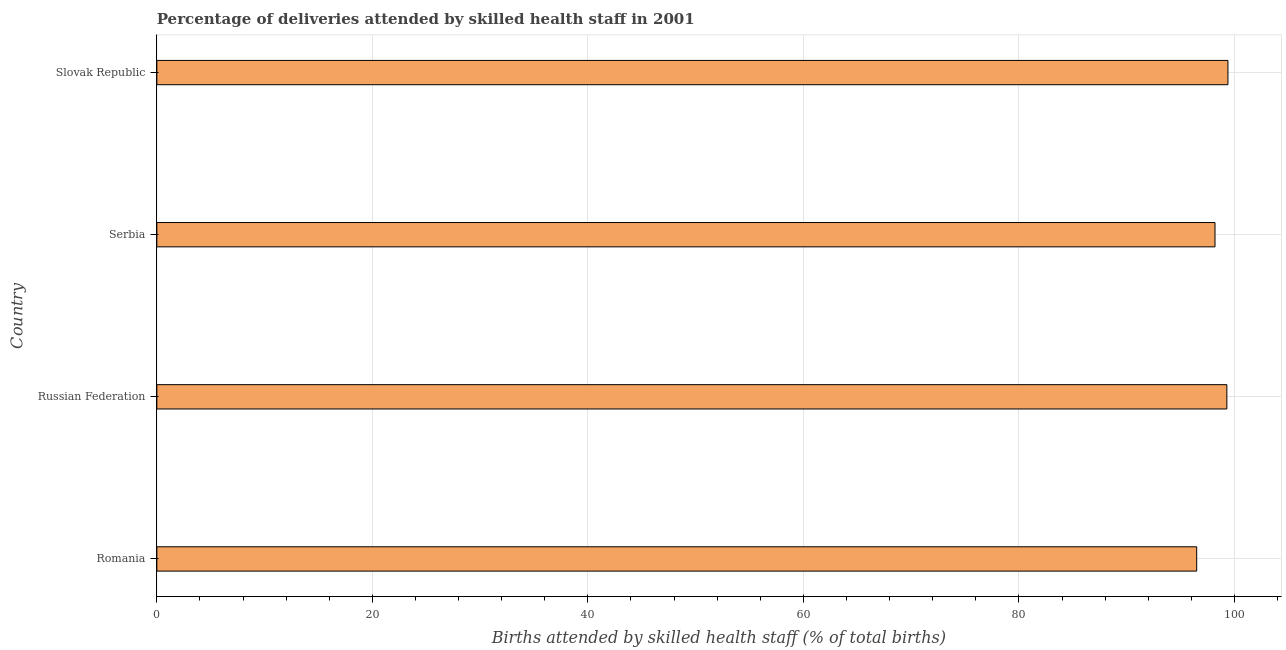Does the graph contain grids?
Ensure brevity in your answer.  Yes. What is the title of the graph?
Offer a terse response. Percentage of deliveries attended by skilled health staff in 2001. What is the label or title of the X-axis?
Provide a succinct answer. Births attended by skilled health staff (% of total births). What is the number of births attended by skilled health staff in Slovak Republic?
Ensure brevity in your answer.  99.4. Across all countries, what is the maximum number of births attended by skilled health staff?
Make the answer very short. 99.4. Across all countries, what is the minimum number of births attended by skilled health staff?
Provide a succinct answer. 96.5. In which country was the number of births attended by skilled health staff maximum?
Offer a terse response. Slovak Republic. In which country was the number of births attended by skilled health staff minimum?
Provide a succinct answer. Romania. What is the sum of the number of births attended by skilled health staff?
Offer a very short reply. 393.4. What is the difference between the number of births attended by skilled health staff in Romania and Slovak Republic?
Ensure brevity in your answer.  -2.9. What is the average number of births attended by skilled health staff per country?
Provide a succinct answer. 98.35. What is the median number of births attended by skilled health staff?
Your response must be concise. 98.75. Is the difference between the number of births attended by skilled health staff in Romania and Serbia greater than the difference between any two countries?
Ensure brevity in your answer.  No. What is the difference between the highest and the second highest number of births attended by skilled health staff?
Ensure brevity in your answer.  0.1. What is the difference between the highest and the lowest number of births attended by skilled health staff?
Keep it short and to the point. 2.9. In how many countries, is the number of births attended by skilled health staff greater than the average number of births attended by skilled health staff taken over all countries?
Provide a short and direct response. 2. How many countries are there in the graph?
Keep it short and to the point. 4. What is the difference between two consecutive major ticks on the X-axis?
Your response must be concise. 20. Are the values on the major ticks of X-axis written in scientific E-notation?
Offer a terse response. No. What is the Births attended by skilled health staff (% of total births) in Romania?
Offer a very short reply. 96.5. What is the Births attended by skilled health staff (% of total births) of Russian Federation?
Provide a succinct answer. 99.3. What is the Births attended by skilled health staff (% of total births) in Serbia?
Keep it short and to the point. 98.2. What is the Births attended by skilled health staff (% of total births) of Slovak Republic?
Your response must be concise. 99.4. What is the difference between the Births attended by skilled health staff (% of total births) in Romania and Serbia?
Offer a very short reply. -1.7. What is the difference between the Births attended by skilled health staff (% of total births) in Romania and Slovak Republic?
Give a very brief answer. -2.9. What is the difference between the Births attended by skilled health staff (% of total births) in Serbia and Slovak Republic?
Your answer should be very brief. -1.2. 